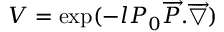<formula> <loc_0><loc_0><loc_500><loc_500>V = \exp ( - l P _ { 0 } \overrightarrow { P } . \overrightarrow { \bigtriangledown } )</formula> 